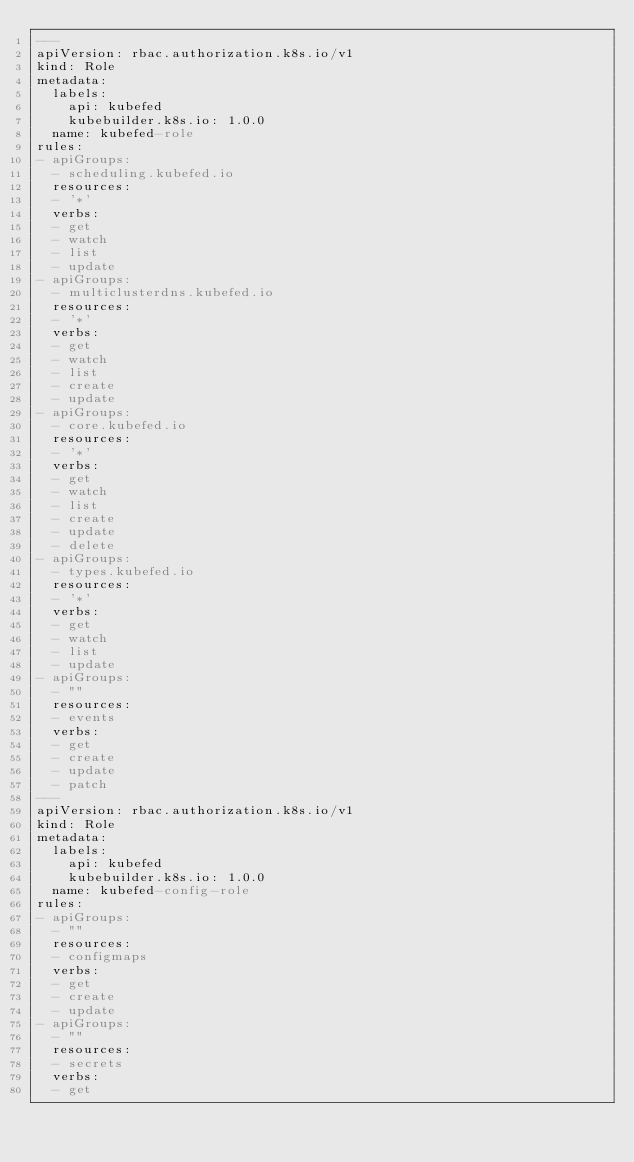<code> <loc_0><loc_0><loc_500><loc_500><_YAML_>---
apiVersion: rbac.authorization.k8s.io/v1
kind: Role
metadata:
  labels:
    api: kubefed
    kubebuilder.k8s.io: 1.0.0
  name: kubefed-role
rules:
- apiGroups:
  - scheduling.kubefed.io
  resources:
  - '*'
  verbs:
  - get
  - watch
  - list
  - update
- apiGroups:
  - multiclusterdns.kubefed.io
  resources:
  - '*'
  verbs:
  - get
  - watch
  - list
  - create
  - update
- apiGroups:
  - core.kubefed.io
  resources:
  - '*'
  verbs:
  - get
  - watch
  - list
  - create
  - update
  - delete
- apiGroups:
  - types.kubefed.io
  resources:
  - '*'
  verbs:
  - get
  - watch
  - list
  - update
- apiGroups:
  - ""
  resources:
  - events
  verbs:
  - get
  - create
  - update
  - patch
---
apiVersion: rbac.authorization.k8s.io/v1
kind: Role
metadata:
  labels:
    api: kubefed
    kubebuilder.k8s.io: 1.0.0
  name: kubefed-config-role
rules:
- apiGroups:
  - ""
  resources:
  - configmaps
  verbs:
  - get
  - create
  - update
- apiGroups:
  - ""
  resources:
  - secrets
  verbs:
  - get
</code> 